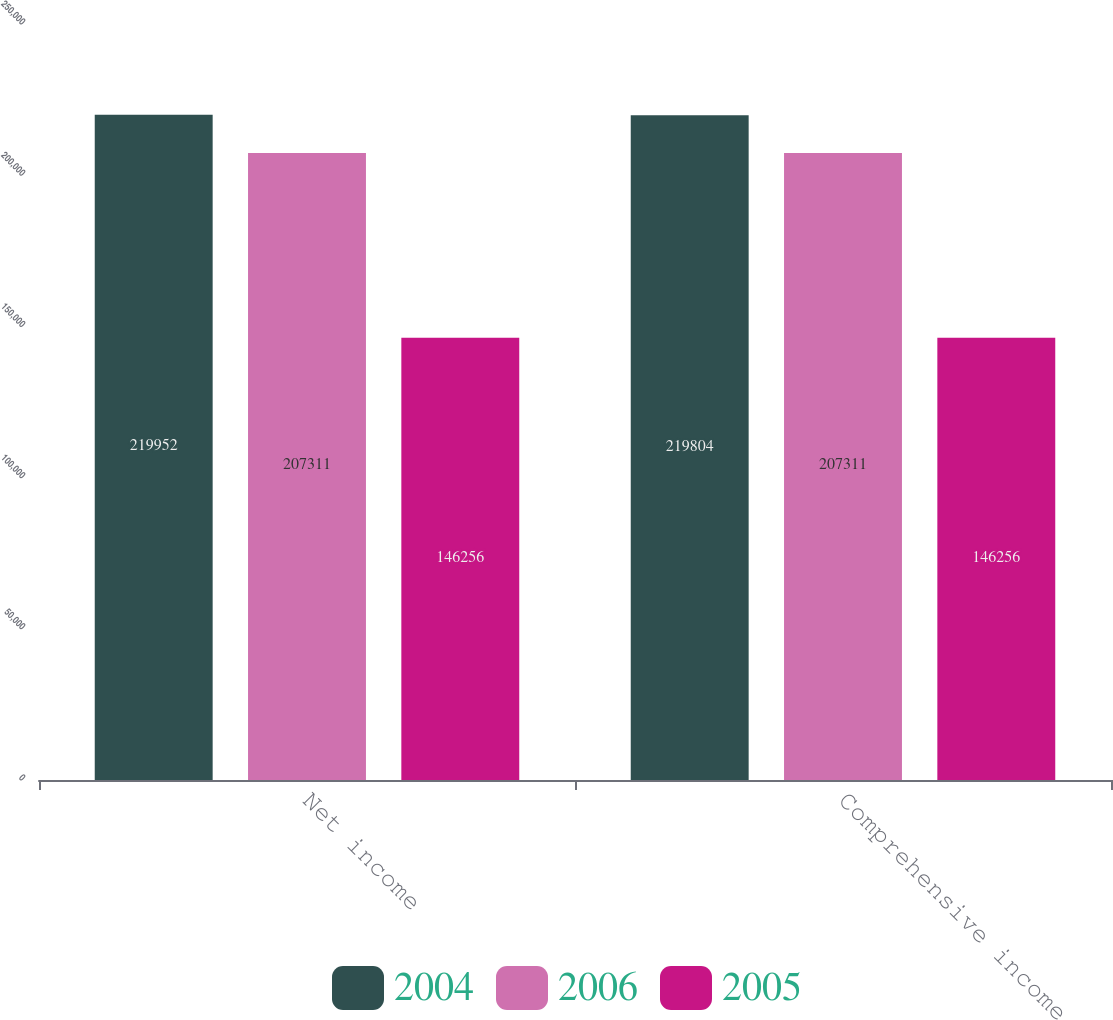Convert chart to OTSL. <chart><loc_0><loc_0><loc_500><loc_500><stacked_bar_chart><ecel><fcel>Net income<fcel>Comprehensive income<nl><fcel>2004<fcel>219952<fcel>219804<nl><fcel>2006<fcel>207311<fcel>207311<nl><fcel>2005<fcel>146256<fcel>146256<nl></chart> 